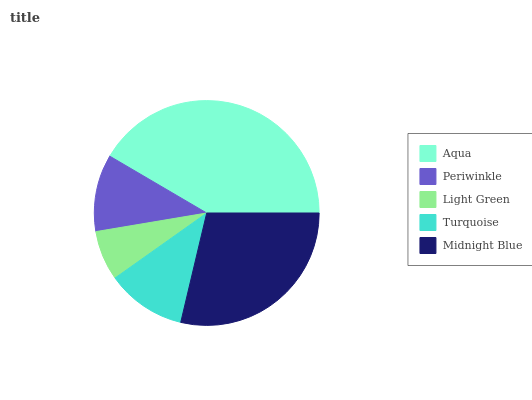Is Light Green the minimum?
Answer yes or no. Yes. Is Aqua the maximum?
Answer yes or no. Yes. Is Periwinkle the minimum?
Answer yes or no. No. Is Periwinkle the maximum?
Answer yes or no. No. Is Aqua greater than Periwinkle?
Answer yes or no. Yes. Is Periwinkle less than Aqua?
Answer yes or no. Yes. Is Periwinkle greater than Aqua?
Answer yes or no. No. Is Aqua less than Periwinkle?
Answer yes or no. No. Is Turquoise the high median?
Answer yes or no. Yes. Is Turquoise the low median?
Answer yes or no. Yes. Is Aqua the high median?
Answer yes or no. No. Is Periwinkle the low median?
Answer yes or no. No. 